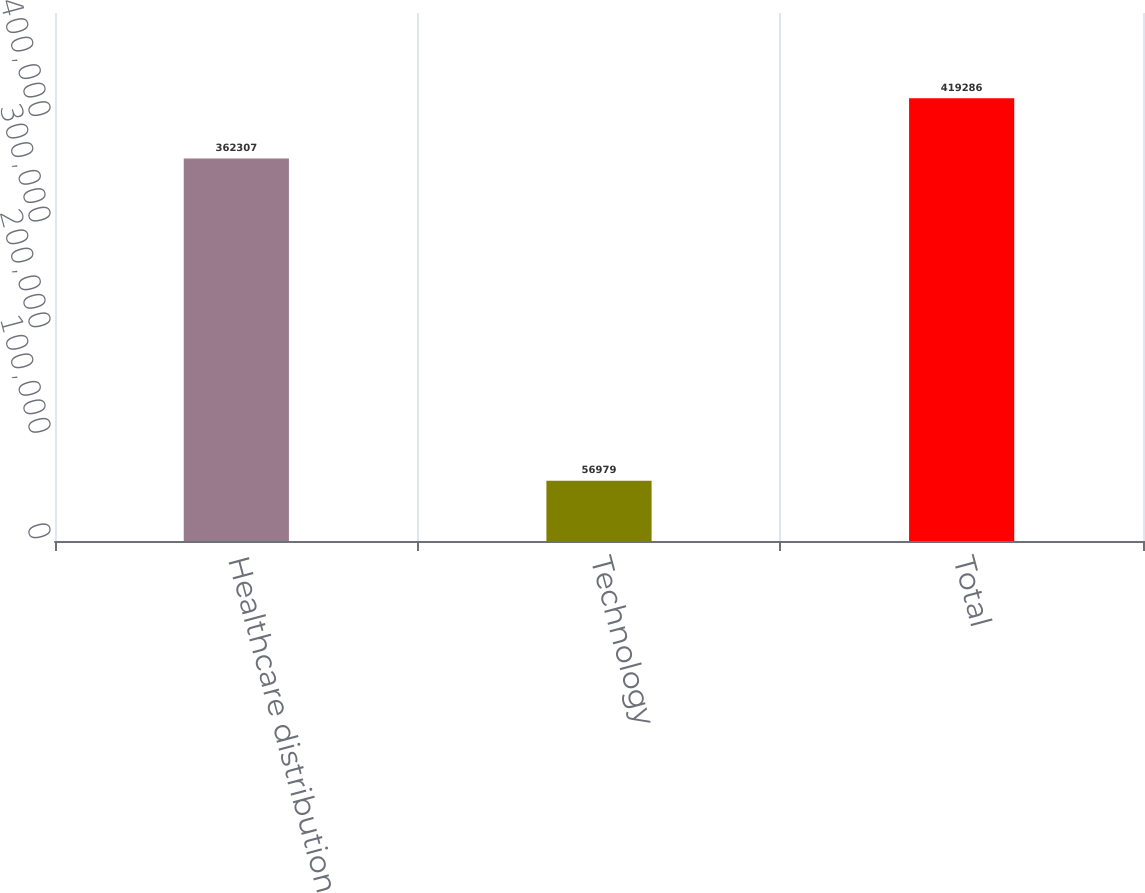Convert chart to OTSL. <chart><loc_0><loc_0><loc_500><loc_500><bar_chart><fcel>Healthcare distribution<fcel>Technology<fcel>Total<nl><fcel>362307<fcel>56979<fcel>419286<nl></chart> 